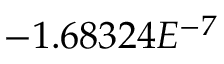<formula> <loc_0><loc_0><loc_500><loc_500>- 1 . 6 8 3 2 4 E ^ { - 7 }</formula> 